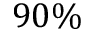<formula> <loc_0><loc_0><loc_500><loc_500>9 0 \%</formula> 